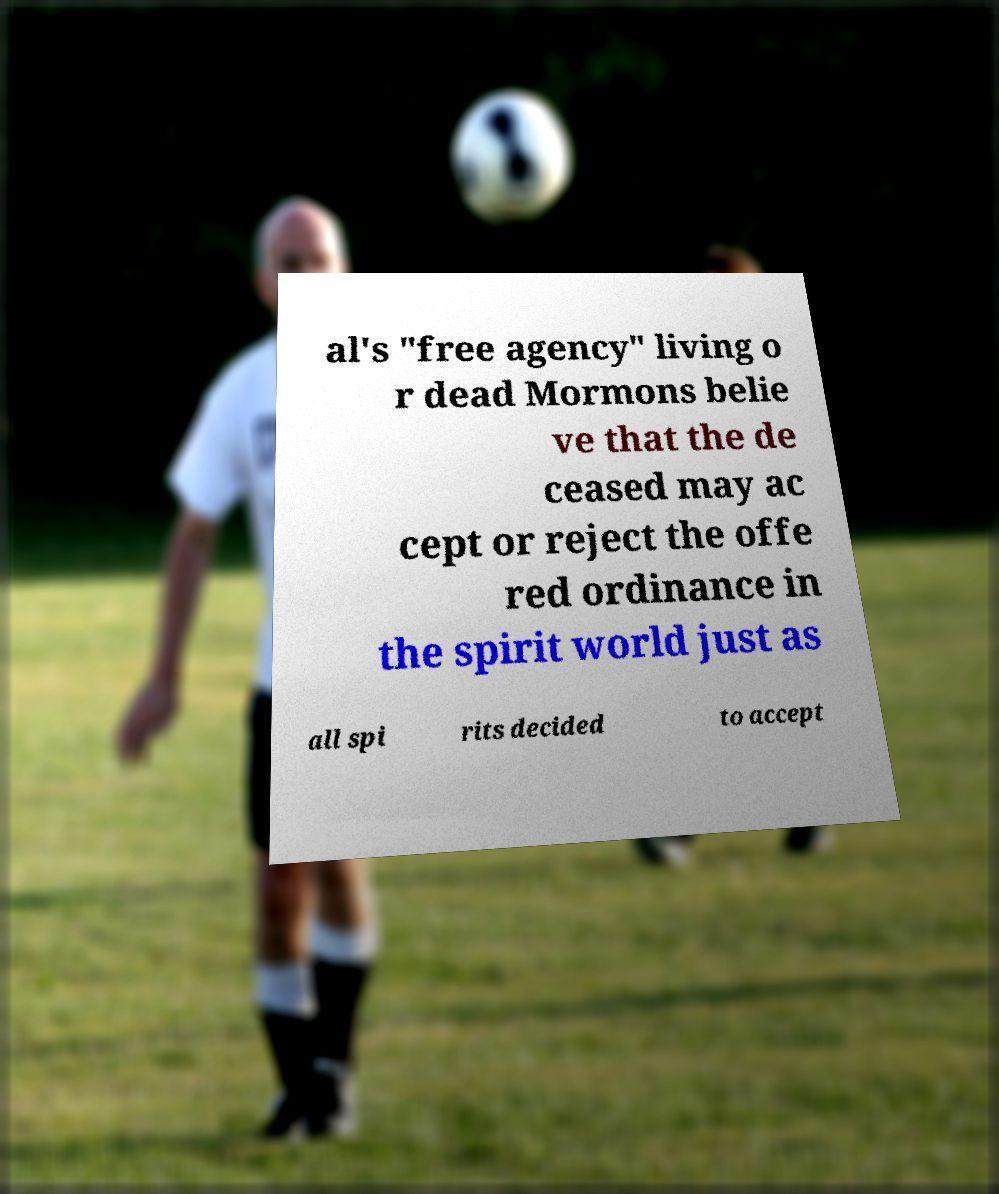Can you accurately transcribe the text from the provided image for me? al's "free agency" living o r dead Mormons belie ve that the de ceased may ac cept or reject the offe red ordinance in the spirit world just as all spi rits decided to accept 